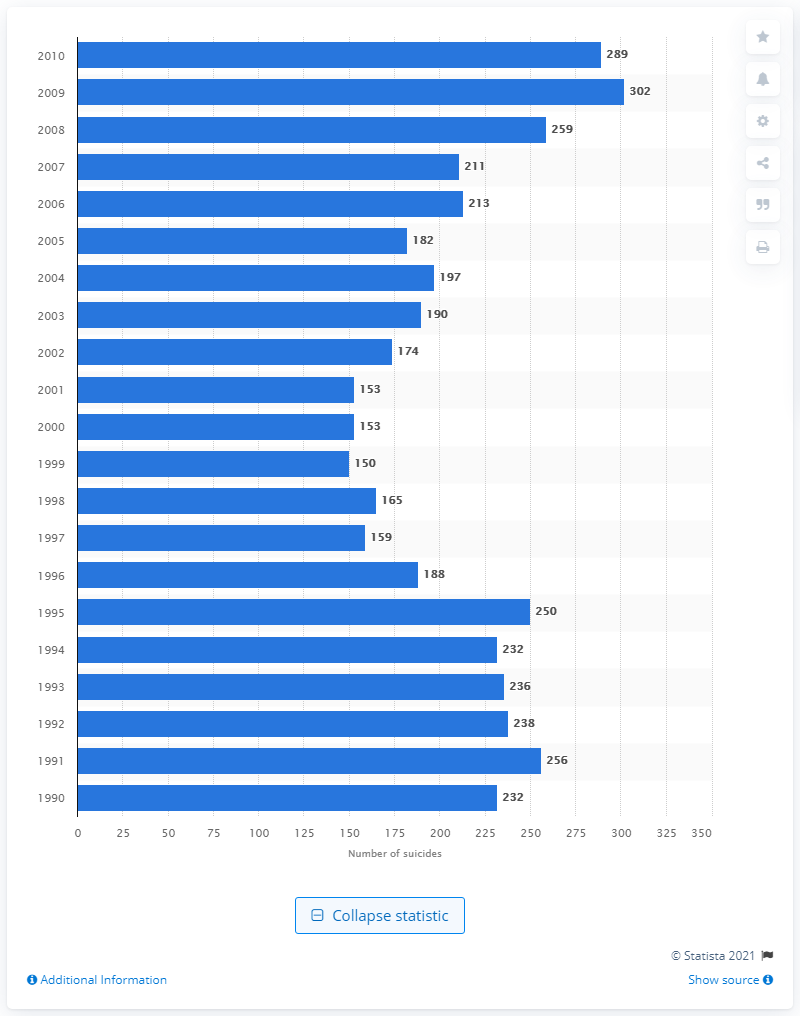Highlight a few significant elements in this photo. In 2010, a total of 289 active duty U.S. military personnel committed suicide. 